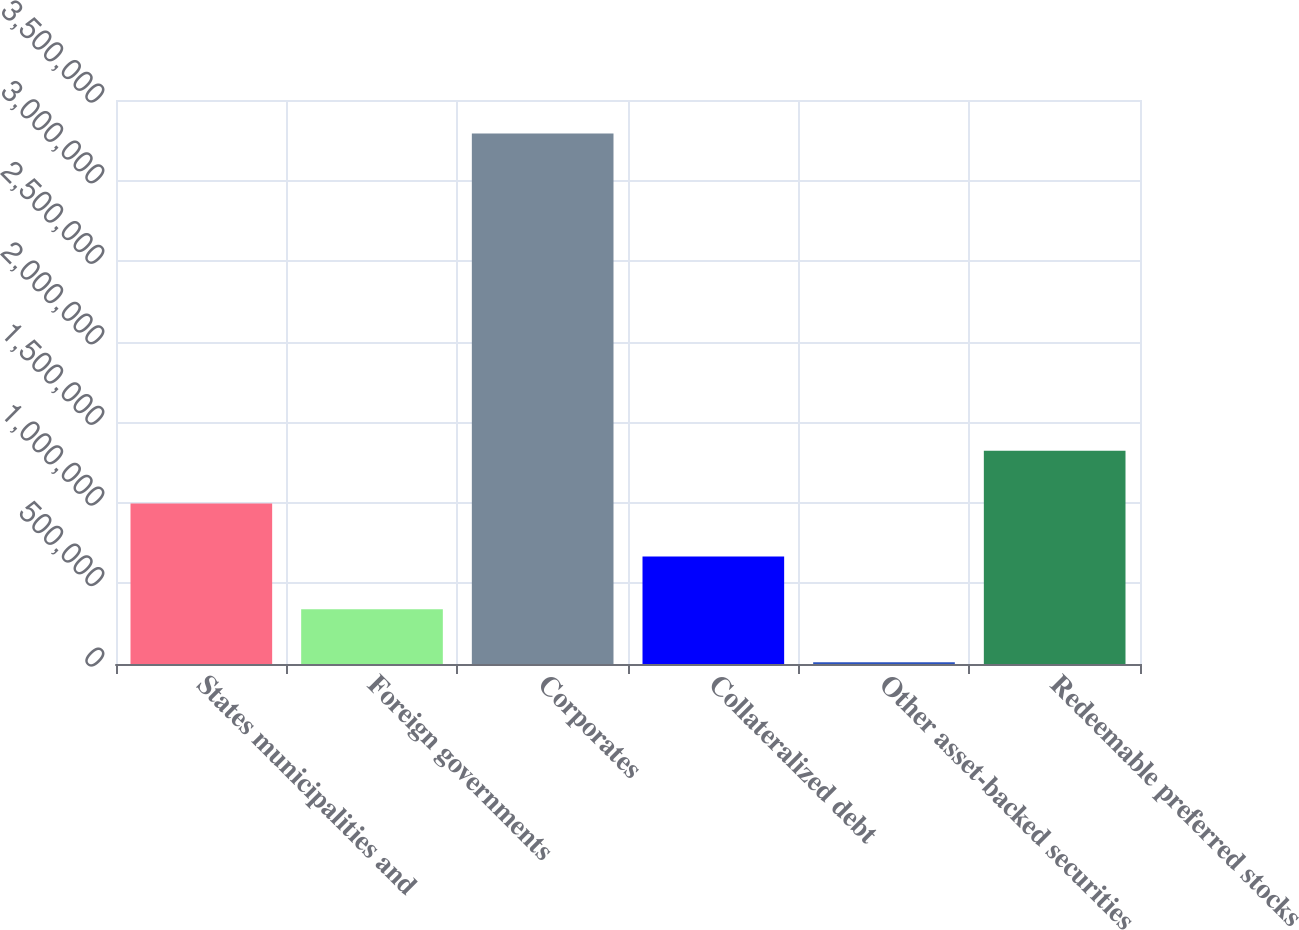Convert chart to OTSL. <chart><loc_0><loc_0><loc_500><loc_500><bar_chart><fcel>States municipalities and<fcel>Foreign governments<fcel>Corporates<fcel>Collateralized debt<fcel>Other asset-backed securities<fcel>Redeemable preferred stocks<nl><fcel>995446<fcel>339047<fcel>3.29284e+06<fcel>667246<fcel>10847<fcel>1.32365e+06<nl></chart> 